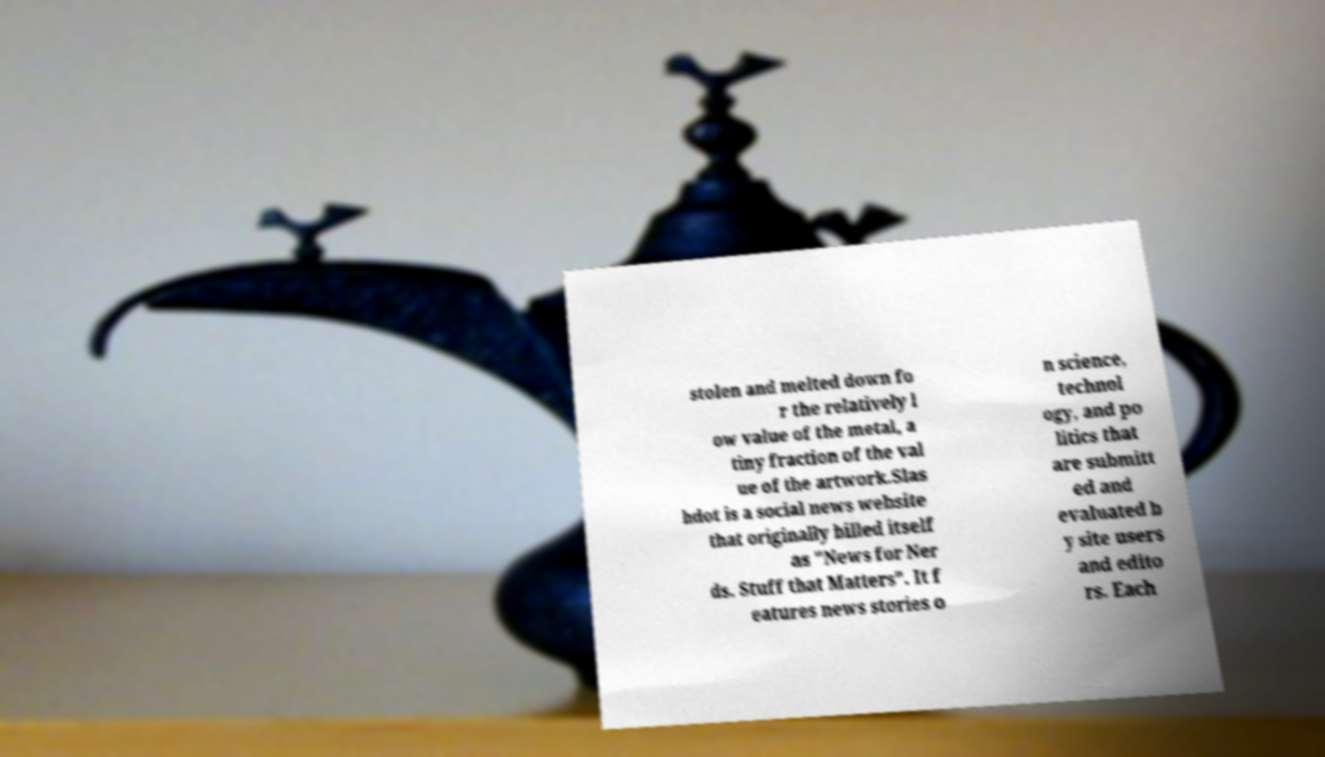What messages or text are displayed in this image? I need them in a readable, typed format. stolen and melted down fo r the relatively l ow value of the metal, a tiny fraction of the val ue of the artwork.Slas hdot is a social news website that originally billed itself as "News for Ner ds. Stuff that Matters". It f eatures news stories o n science, technol ogy, and po litics that are submitt ed and evaluated b y site users and edito rs. Each 